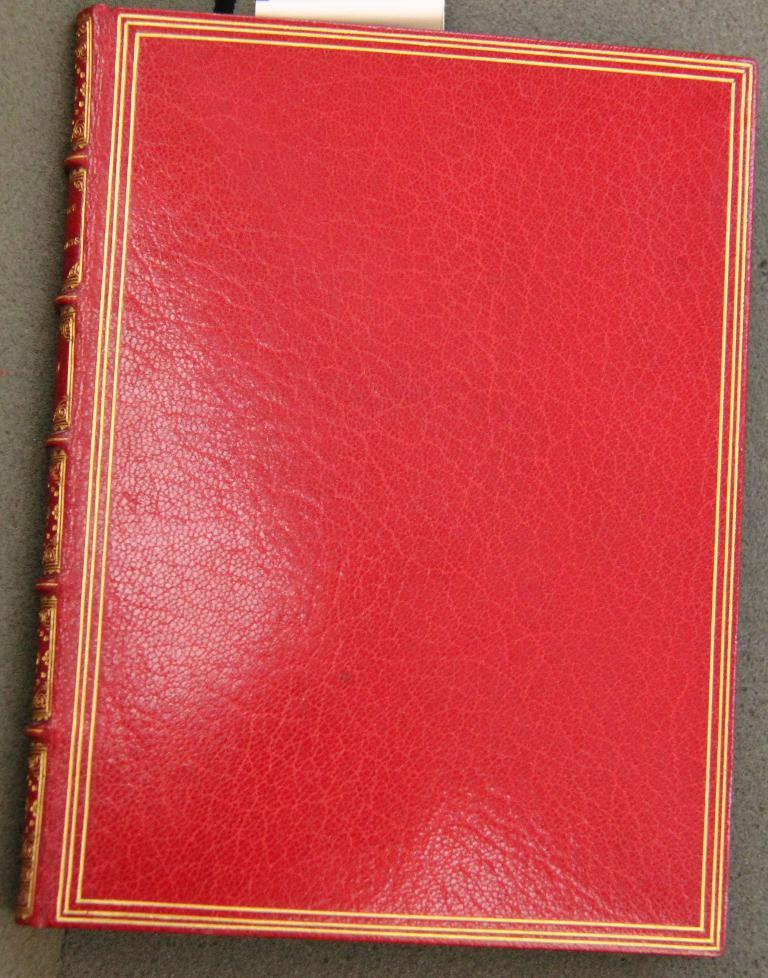What is the main subject in the middle of the image? There is a red color object in the middle of the image. What might the red color object be? The object appears to be a book. What type of roof can be seen on the shop in the image? There is no shop or roof present in the image; it only features a red color object, which appears to be a book. How many trees are visible in the image? There are no trees visible in the image; it only features a red color object, which appears to be a book. 